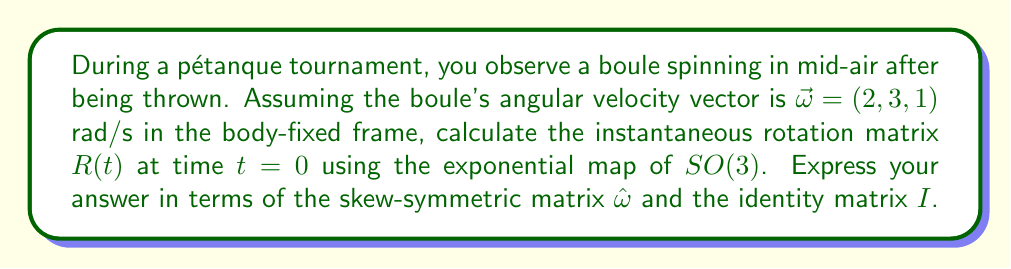Can you solve this math problem? To solve this problem, we'll use the theory of the Special Orthogonal group $SO(3)$ and its Lie algebra $\mathfrak{so}(3)$. The steps are as follows:

1) First, we need to construct the skew-symmetric matrix $\hat{\omega}$ from the angular velocity vector $\vec{\omega} = (2, 3, 1)$. The skew-symmetric matrix is given by:

   $$\hat{\omega} = \begin{pmatrix}
   0 & -\omega_3 & \omega_2 \\
   \omega_3 & 0 & -\omega_1 \\
   -\omega_2 & \omega_1 & 0
   \end{pmatrix} = \begin{pmatrix}
   0 & -1 & 3 \\
   1 & 0 & -2 \\
   -3 & 2 & 0
   \end{pmatrix}$$

2) The rotation matrix $R(t)$ is given by the exponential map:

   $$R(t) = \exp(t\hat{\omega})$$

3) At $t=0$, this becomes:

   $$R(0) = \exp(0 \cdot \hat{\omega}) = \exp(0) = I$$

   where $I$ is the $3\times3$ identity matrix.

4) However, to express this in terms of $\hat{\omega}$ and $I$ as requested, we can use the first-order Taylor expansion of the matrix exponential:

   $$\exp(X) \approx I + X$$

5) Therefore, we can approximate $R(t)$ for small $t$ as:

   $$R(t) \approx I + t\hat{\omega}$$

6) This gives us the desired form, expressing $R(t)$ in terms of $\hat{\omega}$ and $I$.
Answer: $R(t) = I + t\hat{\omega}$, where $I$ is the $3\times3$ identity matrix and $\hat{\omega}$ is the skew-symmetric matrix derived from the angular velocity vector. 